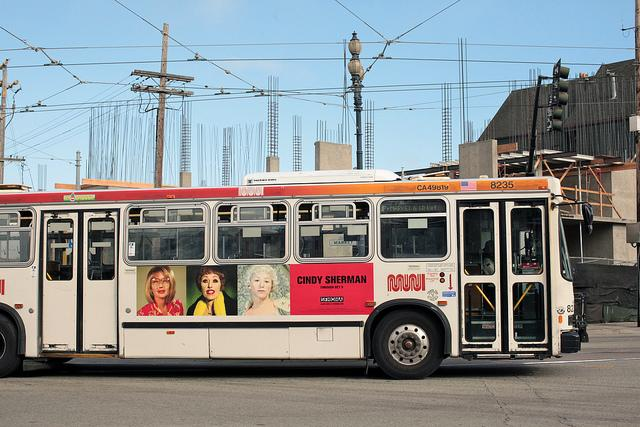What is on the side of the bus?

Choices:
A) digital signs
B) destination
C) advertisement
D) railings advertisement 